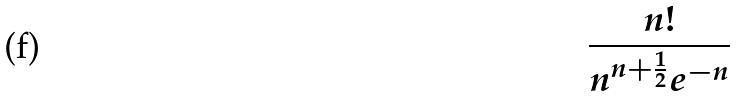<formula> <loc_0><loc_0><loc_500><loc_500>\frac { n ! } { n ^ { n + \frac { 1 } { 2 } } e ^ { - n } }</formula> 